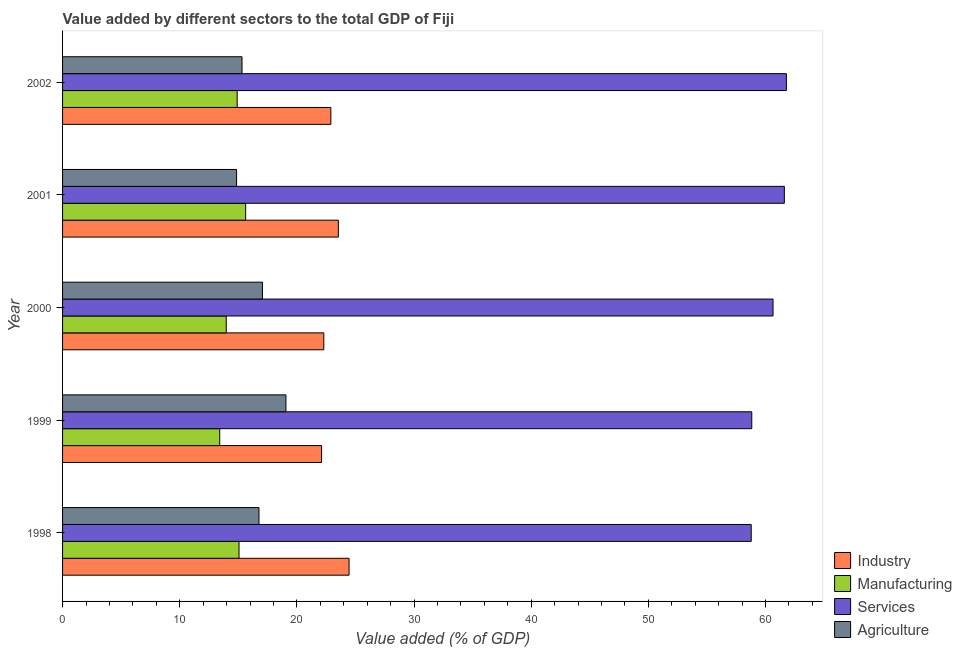How many different coloured bars are there?
Keep it short and to the point. 4. Are the number of bars per tick equal to the number of legend labels?
Ensure brevity in your answer.  Yes. How many bars are there on the 1st tick from the bottom?
Your answer should be compact. 4. What is the value added by industrial sector in 2002?
Ensure brevity in your answer.  22.9. Across all years, what is the maximum value added by services sector?
Ensure brevity in your answer.  61.78. Across all years, what is the minimum value added by manufacturing sector?
Offer a very short reply. 13.42. What is the total value added by agricultural sector in the graph?
Give a very brief answer. 83.06. What is the difference between the value added by agricultural sector in 1998 and that in 1999?
Give a very brief answer. -2.3. What is the difference between the value added by industrial sector in 2002 and the value added by manufacturing sector in 1998?
Keep it short and to the point. 7.84. What is the average value added by manufacturing sector per year?
Offer a terse response. 14.6. In the year 1998, what is the difference between the value added by manufacturing sector and value added by industrial sector?
Provide a short and direct response. -9.39. In how many years, is the value added by agricultural sector greater than 54 %?
Offer a very short reply. 0. What is the difference between the highest and the second highest value added by services sector?
Your answer should be compact. 0.17. What is the difference between the highest and the lowest value added by industrial sector?
Provide a succinct answer. 2.35. What does the 1st bar from the top in 2001 represents?
Offer a terse response. Agriculture. What does the 1st bar from the bottom in 1999 represents?
Give a very brief answer. Industry. How many bars are there?
Make the answer very short. 20. Are all the bars in the graph horizontal?
Your answer should be very brief. Yes. How many years are there in the graph?
Offer a very short reply. 5. What is the difference between two consecutive major ticks on the X-axis?
Your response must be concise. 10. How many legend labels are there?
Ensure brevity in your answer.  4. What is the title of the graph?
Ensure brevity in your answer.  Value added by different sectors to the total GDP of Fiji. What is the label or title of the X-axis?
Provide a succinct answer. Value added (% of GDP). What is the Value added (% of GDP) of Industry in 1998?
Ensure brevity in your answer.  24.45. What is the Value added (% of GDP) of Manufacturing in 1998?
Give a very brief answer. 15.06. What is the Value added (% of GDP) of Services in 1998?
Offer a terse response. 58.78. What is the Value added (% of GDP) in Agriculture in 1998?
Your answer should be compact. 16.77. What is the Value added (% of GDP) in Industry in 1999?
Your answer should be compact. 22.11. What is the Value added (% of GDP) of Manufacturing in 1999?
Make the answer very short. 13.42. What is the Value added (% of GDP) in Services in 1999?
Offer a terse response. 58.83. What is the Value added (% of GDP) of Agriculture in 1999?
Make the answer very short. 19.06. What is the Value added (% of GDP) of Industry in 2000?
Ensure brevity in your answer.  22.3. What is the Value added (% of GDP) in Manufacturing in 2000?
Your answer should be compact. 13.97. What is the Value added (% of GDP) of Services in 2000?
Offer a terse response. 60.64. What is the Value added (% of GDP) in Agriculture in 2000?
Keep it short and to the point. 17.06. What is the Value added (% of GDP) in Industry in 2001?
Provide a short and direct response. 23.54. What is the Value added (% of GDP) in Manufacturing in 2001?
Make the answer very short. 15.63. What is the Value added (% of GDP) in Services in 2001?
Give a very brief answer. 61.61. What is the Value added (% of GDP) of Agriculture in 2001?
Keep it short and to the point. 14.85. What is the Value added (% of GDP) in Industry in 2002?
Keep it short and to the point. 22.9. What is the Value added (% of GDP) of Manufacturing in 2002?
Make the answer very short. 14.9. What is the Value added (% of GDP) in Services in 2002?
Your response must be concise. 61.78. What is the Value added (% of GDP) in Agriculture in 2002?
Your answer should be very brief. 15.32. Across all years, what is the maximum Value added (% of GDP) in Industry?
Offer a very short reply. 24.45. Across all years, what is the maximum Value added (% of GDP) of Manufacturing?
Offer a very short reply. 15.63. Across all years, what is the maximum Value added (% of GDP) in Services?
Your answer should be compact. 61.78. Across all years, what is the maximum Value added (% of GDP) of Agriculture?
Your answer should be compact. 19.06. Across all years, what is the minimum Value added (% of GDP) of Industry?
Your response must be concise. 22.11. Across all years, what is the minimum Value added (% of GDP) in Manufacturing?
Provide a succinct answer. 13.42. Across all years, what is the minimum Value added (% of GDP) of Services?
Offer a terse response. 58.78. Across all years, what is the minimum Value added (% of GDP) in Agriculture?
Your answer should be very brief. 14.85. What is the total Value added (% of GDP) in Industry in the graph?
Your response must be concise. 115.3. What is the total Value added (% of GDP) in Manufacturing in the graph?
Provide a succinct answer. 72.98. What is the total Value added (% of GDP) of Services in the graph?
Ensure brevity in your answer.  301.64. What is the total Value added (% of GDP) in Agriculture in the graph?
Provide a succinct answer. 83.06. What is the difference between the Value added (% of GDP) in Industry in 1998 and that in 1999?
Ensure brevity in your answer.  2.35. What is the difference between the Value added (% of GDP) in Manufacturing in 1998 and that in 1999?
Provide a succinct answer. 1.65. What is the difference between the Value added (% of GDP) of Services in 1998 and that in 1999?
Offer a terse response. -0.05. What is the difference between the Value added (% of GDP) of Agriculture in 1998 and that in 1999?
Keep it short and to the point. -2.3. What is the difference between the Value added (% of GDP) in Industry in 1998 and that in 2000?
Give a very brief answer. 2.16. What is the difference between the Value added (% of GDP) of Manufacturing in 1998 and that in 2000?
Offer a terse response. 1.09. What is the difference between the Value added (% of GDP) of Services in 1998 and that in 2000?
Provide a succinct answer. -1.86. What is the difference between the Value added (% of GDP) of Agriculture in 1998 and that in 2000?
Your answer should be very brief. -0.29. What is the difference between the Value added (% of GDP) of Industry in 1998 and that in 2001?
Keep it short and to the point. 0.91. What is the difference between the Value added (% of GDP) of Manufacturing in 1998 and that in 2001?
Your answer should be compact. -0.57. What is the difference between the Value added (% of GDP) of Services in 1998 and that in 2001?
Your response must be concise. -2.83. What is the difference between the Value added (% of GDP) in Agriculture in 1998 and that in 2001?
Ensure brevity in your answer.  1.91. What is the difference between the Value added (% of GDP) of Industry in 1998 and that in 2002?
Give a very brief answer. 1.55. What is the difference between the Value added (% of GDP) in Manufacturing in 1998 and that in 2002?
Your answer should be very brief. 0.16. What is the difference between the Value added (% of GDP) of Services in 1998 and that in 2002?
Your answer should be very brief. -3. What is the difference between the Value added (% of GDP) in Agriculture in 1998 and that in 2002?
Your response must be concise. 1.45. What is the difference between the Value added (% of GDP) of Industry in 1999 and that in 2000?
Give a very brief answer. -0.19. What is the difference between the Value added (% of GDP) in Manufacturing in 1999 and that in 2000?
Your response must be concise. -0.56. What is the difference between the Value added (% of GDP) of Services in 1999 and that in 2000?
Offer a very short reply. -1.81. What is the difference between the Value added (% of GDP) of Agriculture in 1999 and that in 2000?
Provide a succinct answer. 2. What is the difference between the Value added (% of GDP) of Industry in 1999 and that in 2001?
Provide a succinct answer. -1.43. What is the difference between the Value added (% of GDP) in Manufacturing in 1999 and that in 2001?
Provide a short and direct response. -2.21. What is the difference between the Value added (% of GDP) of Services in 1999 and that in 2001?
Your response must be concise. -2.78. What is the difference between the Value added (% of GDP) of Agriculture in 1999 and that in 2001?
Ensure brevity in your answer.  4.21. What is the difference between the Value added (% of GDP) in Industry in 1999 and that in 2002?
Ensure brevity in your answer.  -0.79. What is the difference between the Value added (% of GDP) in Manufacturing in 1999 and that in 2002?
Give a very brief answer. -1.49. What is the difference between the Value added (% of GDP) in Services in 1999 and that in 2002?
Make the answer very short. -2.95. What is the difference between the Value added (% of GDP) in Agriculture in 1999 and that in 2002?
Provide a succinct answer. 3.75. What is the difference between the Value added (% of GDP) of Industry in 2000 and that in 2001?
Give a very brief answer. -1.24. What is the difference between the Value added (% of GDP) in Manufacturing in 2000 and that in 2001?
Provide a succinct answer. -1.66. What is the difference between the Value added (% of GDP) of Services in 2000 and that in 2001?
Offer a very short reply. -0.97. What is the difference between the Value added (% of GDP) of Agriculture in 2000 and that in 2001?
Give a very brief answer. 2.21. What is the difference between the Value added (% of GDP) of Industry in 2000 and that in 2002?
Provide a short and direct response. -0.6. What is the difference between the Value added (% of GDP) in Manufacturing in 2000 and that in 2002?
Ensure brevity in your answer.  -0.93. What is the difference between the Value added (% of GDP) of Services in 2000 and that in 2002?
Your answer should be very brief. -1.14. What is the difference between the Value added (% of GDP) in Agriculture in 2000 and that in 2002?
Provide a short and direct response. 1.74. What is the difference between the Value added (% of GDP) in Industry in 2001 and that in 2002?
Provide a succinct answer. 0.64. What is the difference between the Value added (% of GDP) of Manufacturing in 2001 and that in 2002?
Your answer should be very brief. 0.72. What is the difference between the Value added (% of GDP) in Services in 2001 and that in 2002?
Give a very brief answer. -0.18. What is the difference between the Value added (% of GDP) of Agriculture in 2001 and that in 2002?
Your answer should be compact. -0.46. What is the difference between the Value added (% of GDP) in Industry in 1998 and the Value added (% of GDP) in Manufacturing in 1999?
Make the answer very short. 11.04. What is the difference between the Value added (% of GDP) in Industry in 1998 and the Value added (% of GDP) in Services in 1999?
Ensure brevity in your answer.  -34.37. What is the difference between the Value added (% of GDP) of Industry in 1998 and the Value added (% of GDP) of Agriculture in 1999?
Ensure brevity in your answer.  5.39. What is the difference between the Value added (% of GDP) of Manufacturing in 1998 and the Value added (% of GDP) of Services in 1999?
Provide a short and direct response. -43.77. What is the difference between the Value added (% of GDP) of Manufacturing in 1998 and the Value added (% of GDP) of Agriculture in 1999?
Give a very brief answer. -4. What is the difference between the Value added (% of GDP) of Services in 1998 and the Value added (% of GDP) of Agriculture in 1999?
Your response must be concise. 39.72. What is the difference between the Value added (% of GDP) in Industry in 1998 and the Value added (% of GDP) in Manufacturing in 2000?
Keep it short and to the point. 10.48. What is the difference between the Value added (% of GDP) in Industry in 1998 and the Value added (% of GDP) in Services in 2000?
Keep it short and to the point. -36.19. What is the difference between the Value added (% of GDP) of Industry in 1998 and the Value added (% of GDP) of Agriculture in 2000?
Ensure brevity in your answer.  7.39. What is the difference between the Value added (% of GDP) in Manufacturing in 1998 and the Value added (% of GDP) in Services in 2000?
Provide a short and direct response. -45.58. What is the difference between the Value added (% of GDP) in Manufacturing in 1998 and the Value added (% of GDP) in Agriculture in 2000?
Your answer should be very brief. -2. What is the difference between the Value added (% of GDP) of Services in 1998 and the Value added (% of GDP) of Agriculture in 2000?
Your response must be concise. 41.72. What is the difference between the Value added (% of GDP) of Industry in 1998 and the Value added (% of GDP) of Manufacturing in 2001?
Give a very brief answer. 8.83. What is the difference between the Value added (% of GDP) of Industry in 1998 and the Value added (% of GDP) of Services in 2001?
Your response must be concise. -37.15. What is the difference between the Value added (% of GDP) in Industry in 1998 and the Value added (% of GDP) in Agriculture in 2001?
Your answer should be compact. 9.6. What is the difference between the Value added (% of GDP) of Manufacturing in 1998 and the Value added (% of GDP) of Services in 2001?
Keep it short and to the point. -46.55. What is the difference between the Value added (% of GDP) of Manufacturing in 1998 and the Value added (% of GDP) of Agriculture in 2001?
Provide a succinct answer. 0.21. What is the difference between the Value added (% of GDP) in Services in 1998 and the Value added (% of GDP) in Agriculture in 2001?
Give a very brief answer. 43.93. What is the difference between the Value added (% of GDP) of Industry in 1998 and the Value added (% of GDP) of Manufacturing in 2002?
Your answer should be compact. 9.55. What is the difference between the Value added (% of GDP) of Industry in 1998 and the Value added (% of GDP) of Services in 2002?
Give a very brief answer. -37.33. What is the difference between the Value added (% of GDP) of Industry in 1998 and the Value added (% of GDP) of Agriculture in 2002?
Your answer should be compact. 9.14. What is the difference between the Value added (% of GDP) of Manufacturing in 1998 and the Value added (% of GDP) of Services in 2002?
Keep it short and to the point. -46.72. What is the difference between the Value added (% of GDP) in Manufacturing in 1998 and the Value added (% of GDP) in Agriculture in 2002?
Offer a very short reply. -0.26. What is the difference between the Value added (% of GDP) of Services in 1998 and the Value added (% of GDP) of Agriculture in 2002?
Keep it short and to the point. 43.46. What is the difference between the Value added (% of GDP) in Industry in 1999 and the Value added (% of GDP) in Manufacturing in 2000?
Your response must be concise. 8.14. What is the difference between the Value added (% of GDP) of Industry in 1999 and the Value added (% of GDP) of Services in 2000?
Your response must be concise. -38.53. What is the difference between the Value added (% of GDP) of Industry in 1999 and the Value added (% of GDP) of Agriculture in 2000?
Ensure brevity in your answer.  5.05. What is the difference between the Value added (% of GDP) of Manufacturing in 1999 and the Value added (% of GDP) of Services in 2000?
Provide a succinct answer. -47.23. What is the difference between the Value added (% of GDP) of Manufacturing in 1999 and the Value added (% of GDP) of Agriculture in 2000?
Your answer should be very brief. -3.65. What is the difference between the Value added (% of GDP) in Services in 1999 and the Value added (% of GDP) in Agriculture in 2000?
Provide a succinct answer. 41.77. What is the difference between the Value added (% of GDP) of Industry in 1999 and the Value added (% of GDP) of Manufacturing in 2001?
Give a very brief answer. 6.48. What is the difference between the Value added (% of GDP) of Industry in 1999 and the Value added (% of GDP) of Services in 2001?
Give a very brief answer. -39.5. What is the difference between the Value added (% of GDP) of Industry in 1999 and the Value added (% of GDP) of Agriculture in 2001?
Give a very brief answer. 7.26. What is the difference between the Value added (% of GDP) in Manufacturing in 1999 and the Value added (% of GDP) in Services in 2001?
Your answer should be compact. -48.19. What is the difference between the Value added (% of GDP) in Manufacturing in 1999 and the Value added (% of GDP) in Agriculture in 2001?
Ensure brevity in your answer.  -1.44. What is the difference between the Value added (% of GDP) in Services in 1999 and the Value added (% of GDP) in Agriculture in 2001?
Your response must be concise. 43.98. What is the difference between the Value added (% of GDP) of Industry in 1999 and the Value added (% of GDP) of Manufacturing in 2002?
Your answer should be very brief. 7.2. What is the difference between the Value added (% of GDP) of Industry in 1999 and the Value added (% of GDP) of Services in 2002?
Offer a very short reply. -39.67. What is the difference between the Value added (% of GDP) in Industry in 1999 and the Value added (% of GDP) in Agriculture in 2002?
Provide a short and direct response. 6.79. What is the difference between the Value added (% of GDP) of Manufacturing in 1999 and the Value added (% of GDP) of Services in 2002?
Offer a very short reply. -48.37. What is the difference between the Value added (% of GDP) of Manufacturing in 1999 and the Value added (% of GDP) of Agriculture in 2002?
Ensure brevity in your answer.  -1.9. What is the difference between the Value added (% of GDP) of Services in 1999 and the Value added (% of GDP) of Agriculture in 2002?
Give a very brief answer. 43.51. What is the difference between the Value added (% of GDP) in Industry in 2000 and the Value added (% of GDP) in Manufacturing in 2001?
Ensure brevity in your answer.  6.67. What is the difference between the Value added (% of GDP) in Industry in 2000 and the Value added (% of GDP) in Services in 2001?
Your answer should be very brief. -39.31. What is the difference between the Value added (% of GDP) of Industry in 2000 and the Value added (% of GDP) of Agriculture in 2001?
Your answer should be compact. 7.44. What is the difference between the Value added (% of GDP) in Manufacturing in 2000 and the Value added (% of GDP) in Services in 2001?
Ensure brevity in your answer.  -47.64. What is the difference between the Value added (% of GDP) of Manufacturing in 2000 and the Value added (% of GDP) of Agriculture in 2001?
Provide a short and direct response. -0.88. What is the difference between the Value added (% of GDP) in Services in 2000 and the Value added (% of GDP) in Agriculture in 2001?
Ensure brevity in your answer.  45.79. What is the difference between the Value added (% of GDP) in Industry in 2000 and the Value added (% of GDP) in Manufacturing in 2002?
Make the answer very short. 7.39. What is the difference between the Value added (% of GDP) in Industry in 2000 and the Value added (% of GDP) in Services in 2002?
Provide a short and direct response. -39.48. What is the difference between the Value added (% of GDP) in Industry in 2000 and the Value added (% of GDP) in Agriculture in 2002?
Your response must be concise. 6.98. What is the difference between the Value added (% of GDP) of Manufacturing in 2000 and the Value added (% of GDP) of Services in 2002?
Offer a very short reply. -47.81. What is the difference between the Value added (% of GDP) in Manufacturing in 2000 and the Value added (% of GDP) in Agriculture in 2002?
Your response must be concise. -1.35. What is the difference between the Value added (% of GDP) in Services in 2000 and the Value added (% of GDP) in Agriculture in 2002?
Give a very brief answer. 45.32. What is the difference between the Value added (% of GDP) in Industry in 2001 and the Value added (% of GDP) in Manufacturing in 2002?
Your response must be concise. 8.64. What is the difference between the Value added (% of GDP) in Industry in 2001 and the Value added (% of GDP) in Services in 2002?
Offer a very short reply. -38.24. What is the difference between the Value added (% of GDP) in Industry in 2001 and the Value added (% of GDP) in Agriculture in 2002?
Ensure brevity in your answer.  8.22. What is the difference between the Value added (% of GDP) in Manufacturing in 2001 and the Value added (% of GDP) in Services in 2002?
Provide a short and direct response. -46.16. What is the difference between the Value added (% of GDP) of Manufacturing in 2001 and the Value added (% of GDP) of Agriculture in 2002?
Your answer should be compact. 0.31. What is the difference between the Value added (% of GDP) in Services in 2001 and the Value added (% of GDP) in Agriculture in 2002?
Your response must be concise. 46.29. What is the average Value added (% of GDP) in Industry per year?
Give a very brief answer. 23.06. What is the average Value added (% of GDP) in Manufacturing per year?
Your response must be concise. 14.6. What is the average Value added (% of GDP) in Services per year?
Provide a short and direct response. 60.33. What is the average Value added (% of GDP) of Agriculture per year?
Provide a short and direct response. 16.61. In the year 1998, what is the difference between the Value added (% of GDP) of Industry and Value added (% of GDP) of Manufacturing?
Your response must be concise. 9.39. In the year 1998, what is the difference between the Value added (% of GDP) in Industry and Value added (% of GDP) in Services?
Provide a succinct answer. -34.33. In the year 1998, what is the difference between the Value added (% of GDP) in Industry and Value added (% of GDP) in Agriculture?
Your answer should be compact. 7.69. In the year 1998, what is the difference between the Value added (% of GDP) in Manufacturing and Value added (% of GDP) in Services?
Ensure brevity in your answer.  -43.72. In the year 1998, what is the difference between the Value added (% of GDP) of Manufacturing and Value added (% of GDP) of Agriculture?
Ensure brevity in your answer.  -1.71. In the year 1998, what is the difference between the Value added (% of GDP) in Services and Value added (% of GDP) in Agriculture?
Offer a terse response. 42.01. In the year 1999, what is the difference between the Value added (% of GDP) in Industry and Value added (% of GDP) in Manufacturing?
Your response must be concise. 8.69. In the year 1999, what is the difference between the Value added (% of GDP) of Industry and Value added (% of GDP) of Services?
Your answer should be very brief. -36.72. In the year 1999, what is the difference between the Value added (% of GDP) in Industry and Value added (% of GDP) in Agriculture?
Make the answer very short. 3.04. In the year 1999, what is the difference between the Value added (% of GDP) in Manufacturing and Value added (% of GDP) in Services?
Your answer should be very brief. -45.41. In the year 1999, what is the difference between the Value added (% of GDP) in Manufacturing and Value added (% of GDP) in Agriculture?
Offer a terse response. -5.65. In the year 1999, what is the difference between the Value added (% of GDP) in Services and Value added (% of GDP) in Agriculture?
Ensure brevity in your answer.  39.76. In the year 2000, what is the difference between the Value added (% of GDP) in Industry and Value added (% of GDP) in Manufacturing?
Provide a succinct answer. 8.33. In the year 2000, what is the difference between the Value added (% of GDP) of Industry and Value added (% of GDP) of Services?
Your response must be concise. -38.34. In the year 2000, what is the difference between the Value added (% of GDP) of Industry and Value added (% of GDP) of Agriculture?
Keep it short and to the point. 5.24. In the year 2000, what is the difference between the Value added (% of GDP) in Manufacturing and Value added (% of GDP) in Services?
Offer a very short reply. -46.67. In the year 2000, what is the difference between the Value added (% of GDP) in Manufacturing and Value added (% of GDP) in Agriculture?
Provide a short and direct response. -3.09. In the year 2000, what is the difference between the Value added (% of GDP) in Services and Value added (% of GDP) in Agriculture?
Ensure brevity in your answer.  43.58. In the year 2001, what is the difference between the Value added (% of GDP) in Industry and Value added (% of GDP) in Manufacturing?
Your response must be concise. 7.91. In the year 2001, what is the difference between the Value added (% of GDP) of Industry and Value added (% of GDP) of Services?
Make the answer very short. -38.07. In the year 2001, what is the difference between the Value added (% of GDP) in Industry and Value added (% of GDP) in Agriculture?
Your answer should be very brief. 8.69. In the year 2001, what is the difference between the Value added (% of GDP) of Manufacturing and Value added (% of GDP) of Services?
Give a very brief answer. -45.98. In the year 2001, what is the difference between the Value added (% of GDP) in Manufacturing and Value added (% of GDP) in Agriculture?
Offer a very short reply. 0.77. In the year 2001, what is the difference between the Value added (% of GDP) in Services and Value added (% of GDP) in Agriculture?
Offer a terse response. 46.75. In the year 2002, what is the difference between the Value added (% of GDP) of Industry and Value added (% of GDP) of Manufacturing?
Ensure brevity in your answer.  8. In the year 2002, what is the difference between the Value added (% of GDP) in Industry and Value added (% of GDP) in Services?
Provide a short and direct response. -38.88. In the year 2002, what is the difference between the Value added (% of GDP) of Industry and Value added (% of GDP) of Agriculture?
Make the answer very short. 7.58. In the year 2002, what is the difference between the Value added (% of GDP) in Manufacturing and Value added (% of GDP) in Services?
Keep it short and to the point. -46.88. In the year 2002, what is the difference between the Value added (% of GDP) of Manufacturing and Value added (% of GDP) of Agriculture?
Offer a terse response. -0.41. In the year 2002, what is the difference between the Value added (% of GDP) in Services and Value added (% of GDP) in Agriculture?
Offer a terse response. 46.46. What is the ratio of the Value added (% of GDP) of Industry in 1998 to that in 1999?
Keep it short and to the point. 1.11. What is the ratio of the Value added (% of GDP) of Manufacturing in 1998 to that in 1999?
Ensure brevity in your answer.  1.12. What is the ratio of the Value added (% of GDP) of Services in 1998 to that in 1999?
Offer a very short reply. 1. What is the ratio of the Value added (% of GDP) of Agriculture in 1998 to that in 1999?
Give a very brief answer. 0.88. What is the ratio of the Value added (% of GDP) in Industry in 1998 to that in 2000?
Your answer should be very brief. 1.1. What is the ratio of the Value added (% of GDP) of Manufacturing in 1998 to that in 2000?
Offer a very short reply. 1.08. What is the ratio of the Value added (% of GDP) in Services in 1998 to that in 2000?
Ensure brevity in your answer.  0.97. What is the ratio of the Value added (% of GDP) of Agriculture in 1998 to that in 2000?
Provide a short and direct response. 0.98. What is the ratio of the Value added (% of GDP) in Industry in 1998 to that in 2001?
Ensure brevity in your answer.  1.04. What is the ratio of the Value added (% of GDP) of Manufacturing in 1998 to that in 2001?
Provide a succinct answer. 0.96. What is the ratio of the Value added (% of GDP) of Services in 1998 to that in 2001?
Your answer should be compact. 0.95. What is the ratio of the Value added (% of GDP) in Agriculture in 1998 to that in 2001?
Offer a terse response. 1.13. What is the ratio of the Value added (% of GDP) in Industry in 1998 to that in 2002?
Offer a terse response. 1.07. What is the ratio of the Value added (% of GDP) of Manufacturing in 1998 to that in 2002?
Your response must be concise. 1.01. What is the ratio of the Value added (% of GDP) of Services in 1998 to that in 2002?
Keep it short and to the point. 0.95. What is the ratio of the Value added (% of GDP) in Agriculture in 1998 to that in 2002?
Ensure brevity in your answer.  1.09. What is the ratio of the Value added (% of GDP) of Manufacturing in 1999 to that in 2000?
Offer a very short reply. 0.96. What is the ratio of the Value added (% of GDP) of Services in 1999 to that in 2000?
Provide a short and direct response. 0.97. What is the ratio of the Value added (% of GDP) in Agriculture in 1999 to that in 2000?
Your answer should be compact. 1.12. What is the ratio of the Value added (% of GDP) in Industry in 1999 to that in 2001?
Provide a short and direct response. 0.94. What is the ratio of the Value added (% of GDP) of Manufacturing in 1999 to that in 2001?
Your answer should be compact. 0.86. What is the ratio of the Value added (% of GDP) in Services in 1999 to that in 2001?
Your response must be concise. 0.95. What is the ratio of the Value added (% of GDP) in Agriculture in 1999 to that in 2001?
Your answer should be compact. 1.28. What is the ratio of the Value added (% of GDP) in Industry in 1999 to that in 2002?
Offer a terse response. 0.97. What is the ratio of the Value added (% of GDP) in Manufacturing in 1999 to that in 2002?
Provide a succinct answer. 0.9. What is the ratio of the Value added (% of GDP) of Services in 1999 to that in 2002?
Provide a succinct answer. 0.95. What is the ratio of the Value added (% of GDP) in Agriculture in 1999 to that in 2002?
Keep it short and to the point. 1.24. What is the ratio of the Value added (% of GDP) in Industry in 2000 to that in 2001?
Your response must be concise. 0.95. What is the ratio of the Value added (% of GDP) in Manufacturing in 2000 to that in 2001?
Give a very brief answer. 0.89. What is the ratio of the Value added (% of GDP) in Services in 2000 to that in 2001?
Offer a very short reply. 0.98. What is the ratio of the Value added (% of GDP) in Agriculture in 2000 to that in 2001?
Your answer should be compact. 1.15. What is the ratio of the Value added (% of GDP) in Industry in 2000 to that in 2002?
Provide a short and direct response. 0.97. What is the ratio of the Value added (% of GDP) in Services in 2000 to that in 2002?
Offer a terse response. 0.98. What is the ratio of the Value added (% of GDP) in Agriculture in 2000 to that in 2002?
Your response must be concise. 1.11. What is the ratio of the Value added (% of GDP) in Industry in 2001 to that in 2002?
Your answer should be very brief. 1.03. What is the ratio of the Value added (% of GDP) in Manufacturing in 2001 to that in 2002?
Give a very brief answer. 1.05. What is the ratio of the Value added (% of GDP) of Services in 2001 to that in 2002?
Offer a terse response. 1. What is the ratio of the Value added (% of GDP) in Agriculture in 2001 to that in 2002?
Make the answer very short. 0.97. What is the difference between the highest and the second highest Value added (% of GDP) in Industry?
Keep it short and to the point. 0.91. What is the difference between the highest and the second highest Value added (% of GDP) in Manufacturing?
Keep it short and to the point. 0.57. What is the difference between the highest and the second highest Value added (% of GDP) in Services?
Your answer should be very brief. 0.18. What is the difference between the highest and the second highest Value added (% of GDP) of Agriculture?
Offer a very short reply. 2. What is the difference between the highest and the lowest Value added (% of GDP) of Industry?
Provide a succinct answer. 2.35. What is the difference between the highest and the lowest Value added (% of GDP) of Manufacturing?
Provide a short and direct response. 2.21. What is the difference between the highest and the lowest Value added (% of GDP) in Services?
Keep it short and to the point. 3. What is the difference between the highest and the lowest Value added (% of GDP) of Agriculture?
Your response must be concise. 4.21. 